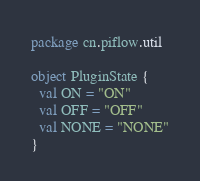Convert code to text. <code><loc_0><loc_0><loc_500><loc_500><_Scala_>package cn.piflow.util

object PluginState {
  val ON = "ON"
  val OFF = "OFF"
  val NONE = "NONE"
}
</code> 